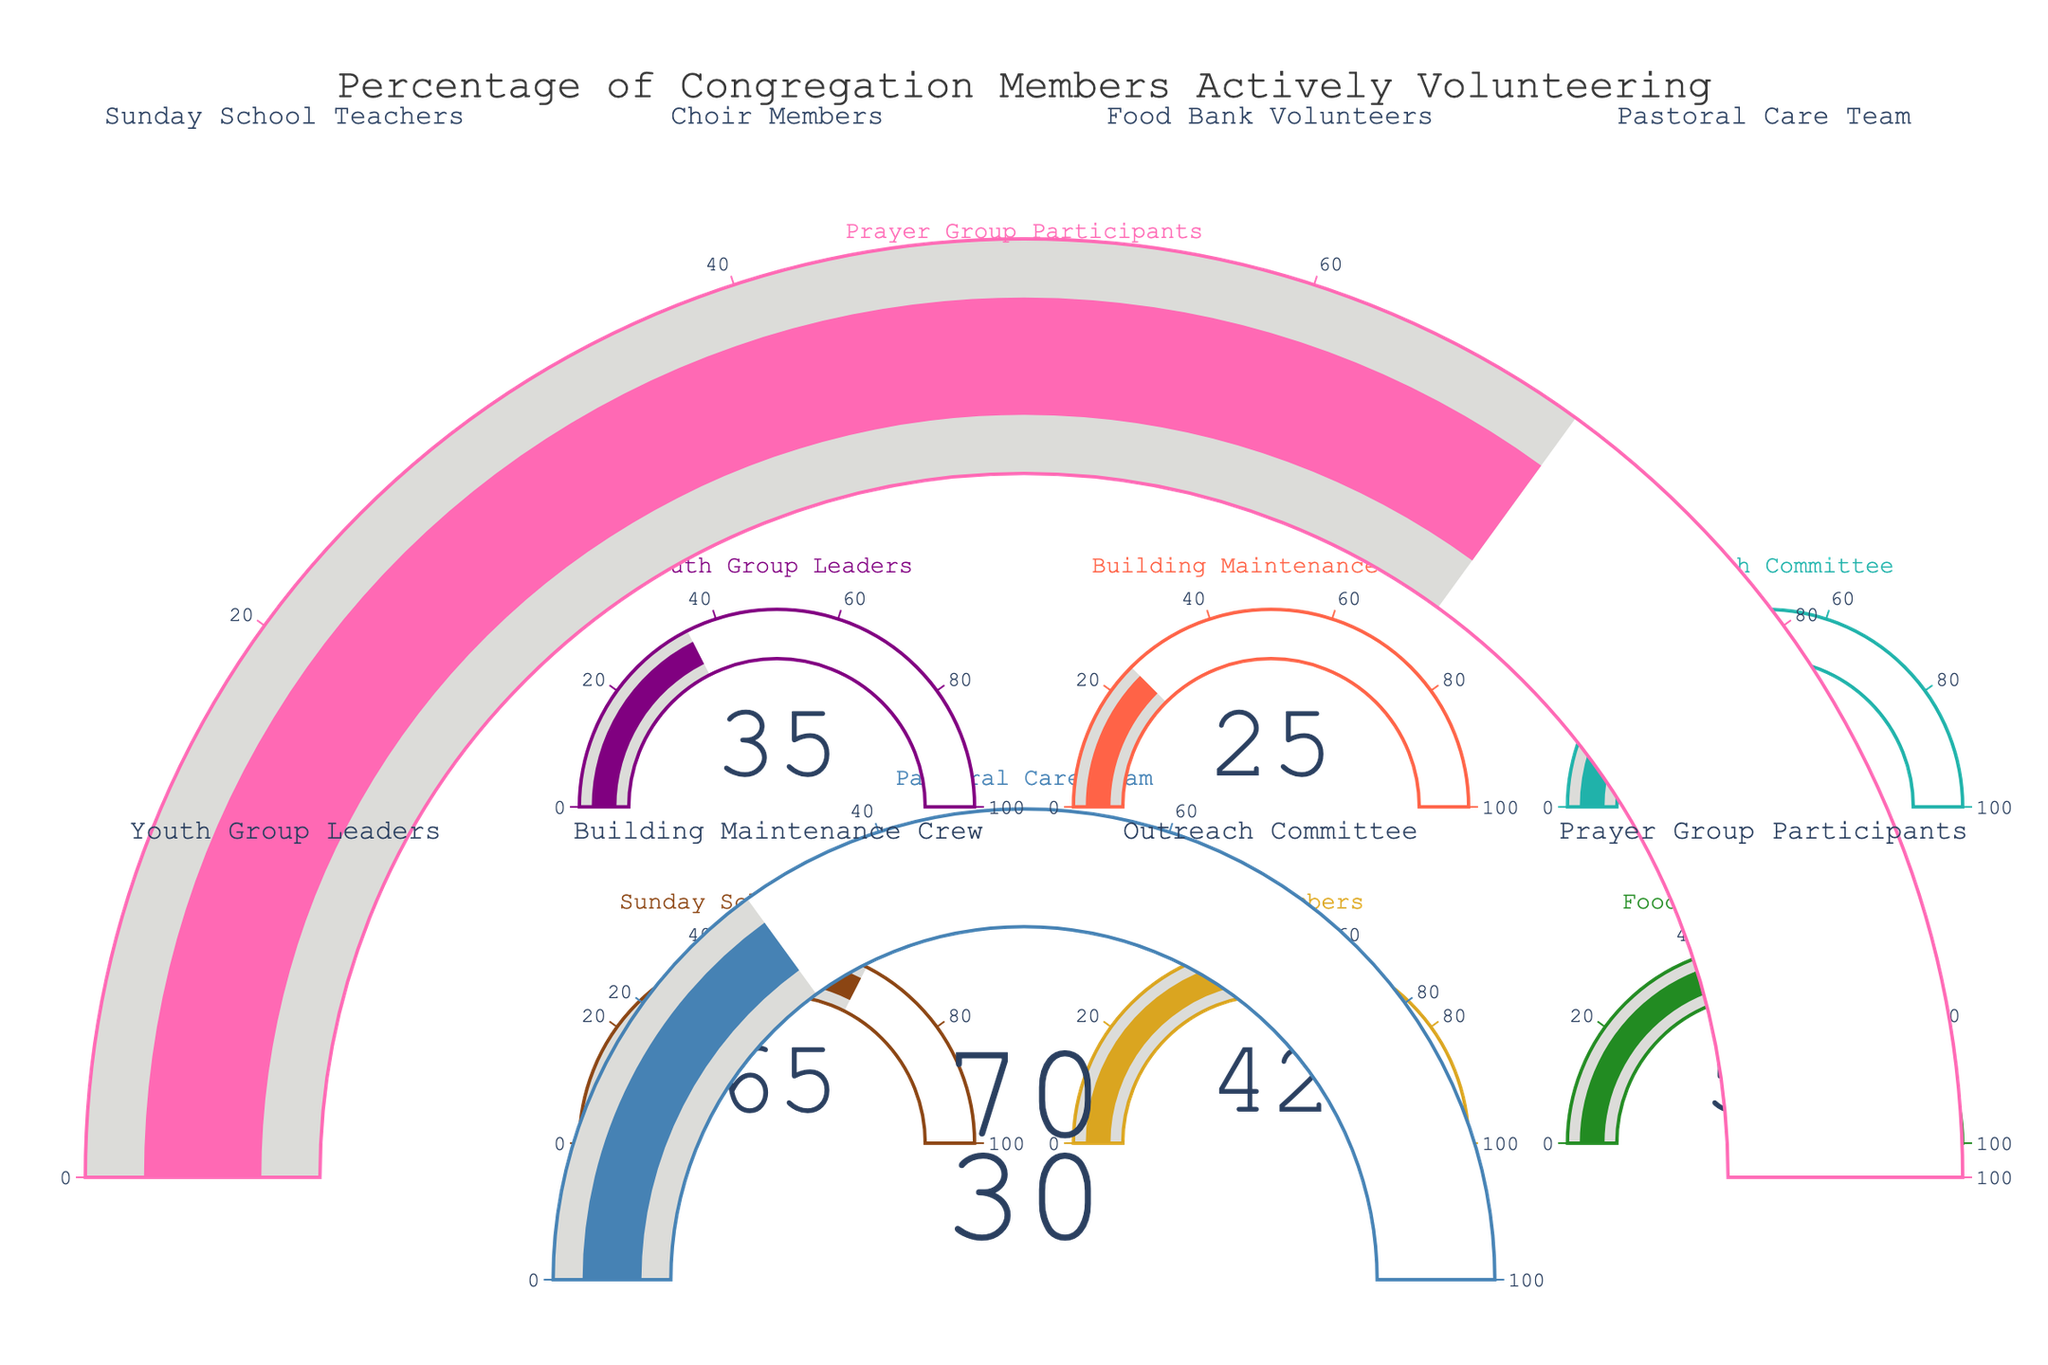What is the percentage of congregation members actively volunteering as Prayer Group Participants? Look at the gauge chart labeled "Prayer Group Participants" and note the value indicated on the gauge, which is 70.
Answer: 70 Which activity has the least percentage of volunteers? Identify the gauge chart with the lowest value. The "Building Maintenance Crew" has the lowest percentage of 25.
Answer: Building Maintenance Crew How much greater is the percentage of Sunday School Teachers compared to Pastoral Care Team members? Find the percentages for both activities: Sunday School Teachers (65) and Pastoral Care Team (30). Subtract the smaller percentage from the larger: 65 - 30.
Answer: 35 What is the average percentage of volunteers in Food Bank Volunteers, Outreach Committee, and Youth Group Leaders? Find the percentages for Food Bank Volunteers (58), Outreach Committee (40), and Youth Group Leaders (35). Sum these percentages and divide by 3: (58 + 40 + 35) / 3.
Answer: 44.33 Which activities have a higher percentage of volunteers than Choir Members? Identify the percentage for Choir Members (42) and then compare it with other activities. The activities with higher percentages are: Sunday School Teachers (65), Food Bank Volunteers (58), Prayer Group Participants (70).
Answer: Sunday School Teachers, Food Bank Volunteers, Prayer Group Participants What is the total percentage of volunteers for the Pastoral Care Team, Youth Group Leaders, and Building Maintenance Crew combined? Find the percentages for each activity: Pastoral Care Team (30), Youth Group Leaders (35), and Building Maintenance Crew (25). Sum these percentages: 30 + 35 + 25.
Answer: 90 What percentage is represented by the Building Maintenance Crew? Look at the gauge chart labeled "Building Maintenance Crew" and note the value indicated on the gauge, which is 25.
Answer: 25 Is the percentage of youth group leaders more than 30? Look at the gauge chart labeled "Youth Group Leaders" and note the value indicated, which is 35. Since 35 > 30, the answer is yes.
Answer: Yes What is the difference in percentage between the activity with the most volunteers and the activity with the least volunteers? Identify the two activities: Prayer Group Participants (70) and Building Maintenance Crew (25). Subtract the smaller percentage from the larger: 70 - 25.
Answer: 45 